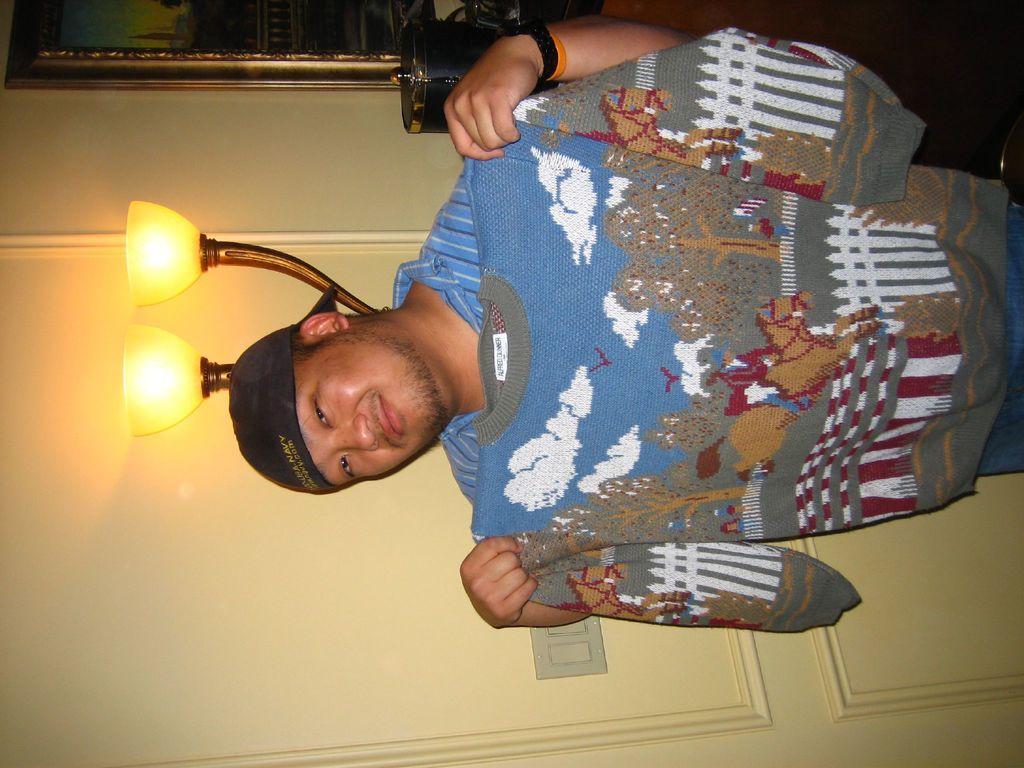Can you describe this image briefly? In the picture we can see a man standing and holding a sweater and he is with the black color cap and behind him we can see a wall and near it, we can see a stand with two lamps to it and beside it we can see a photo frame and a painting in it. 